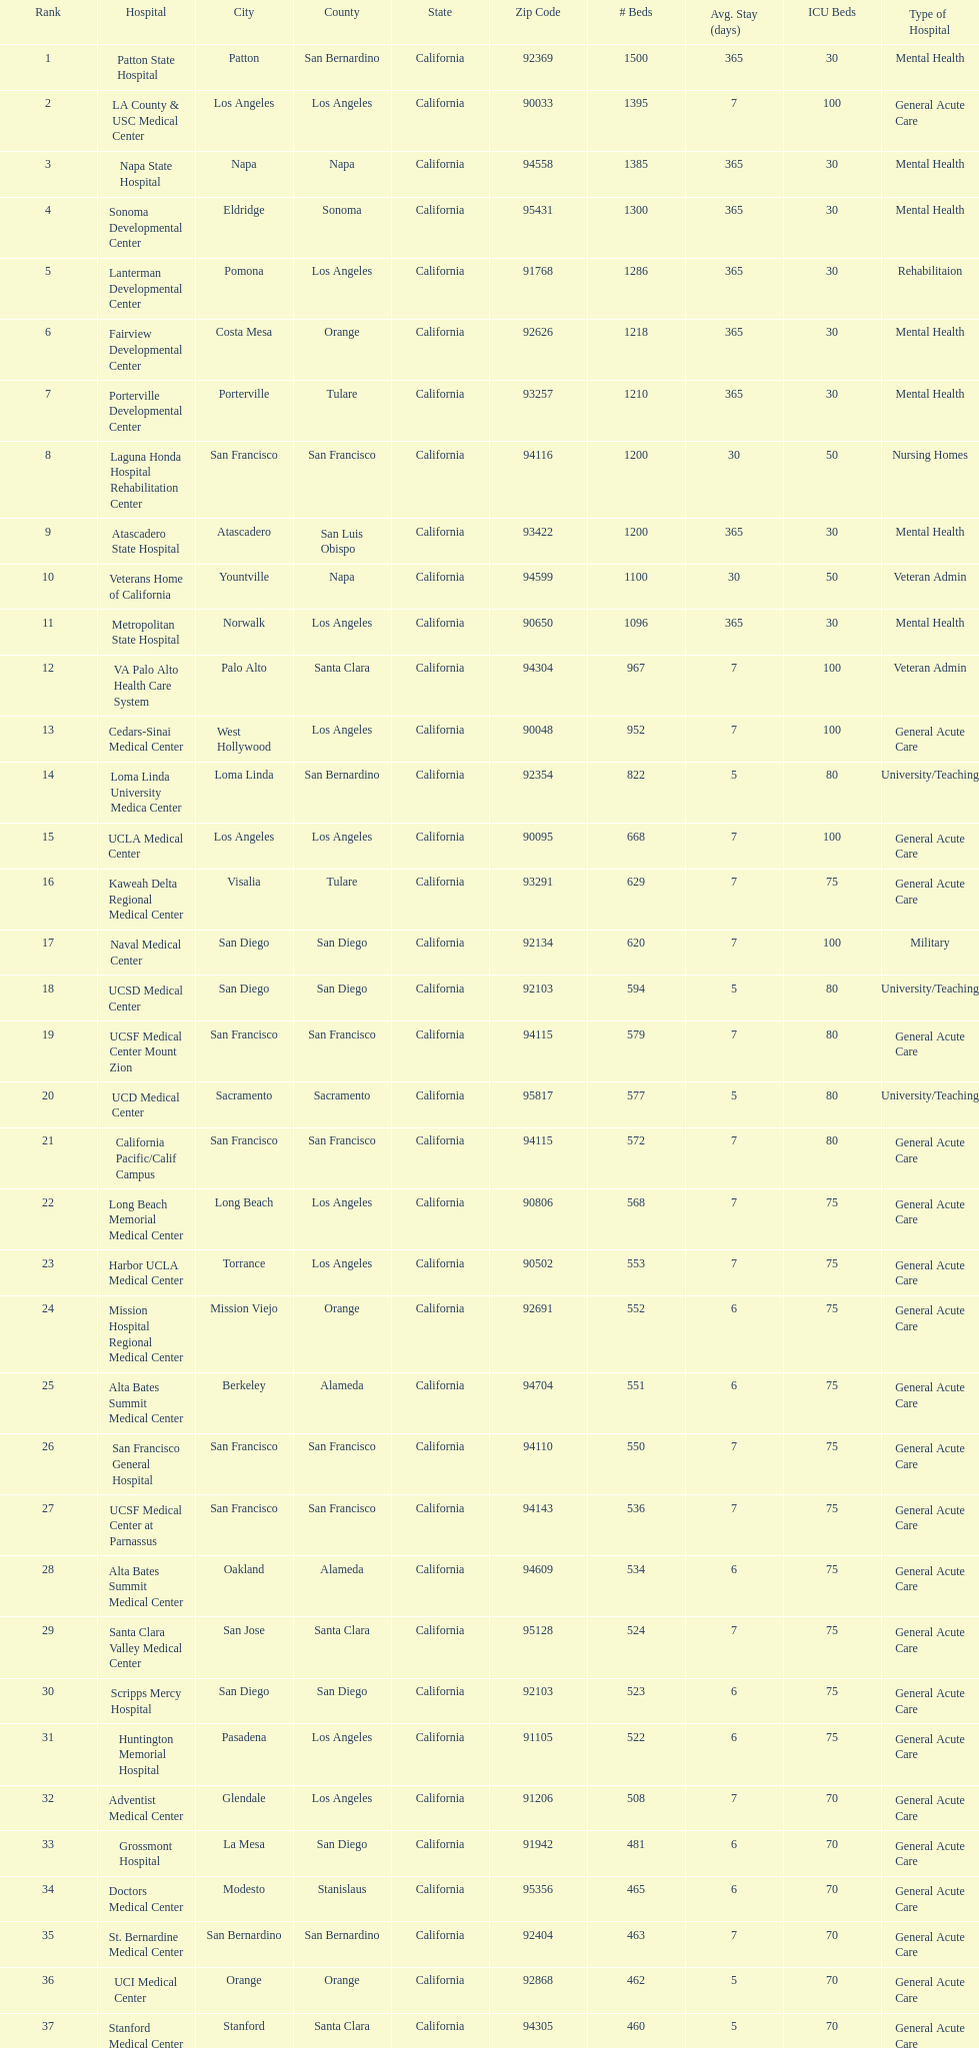How many more general acute care hospitals are there in california than rehabilitation hospitals? 33. 